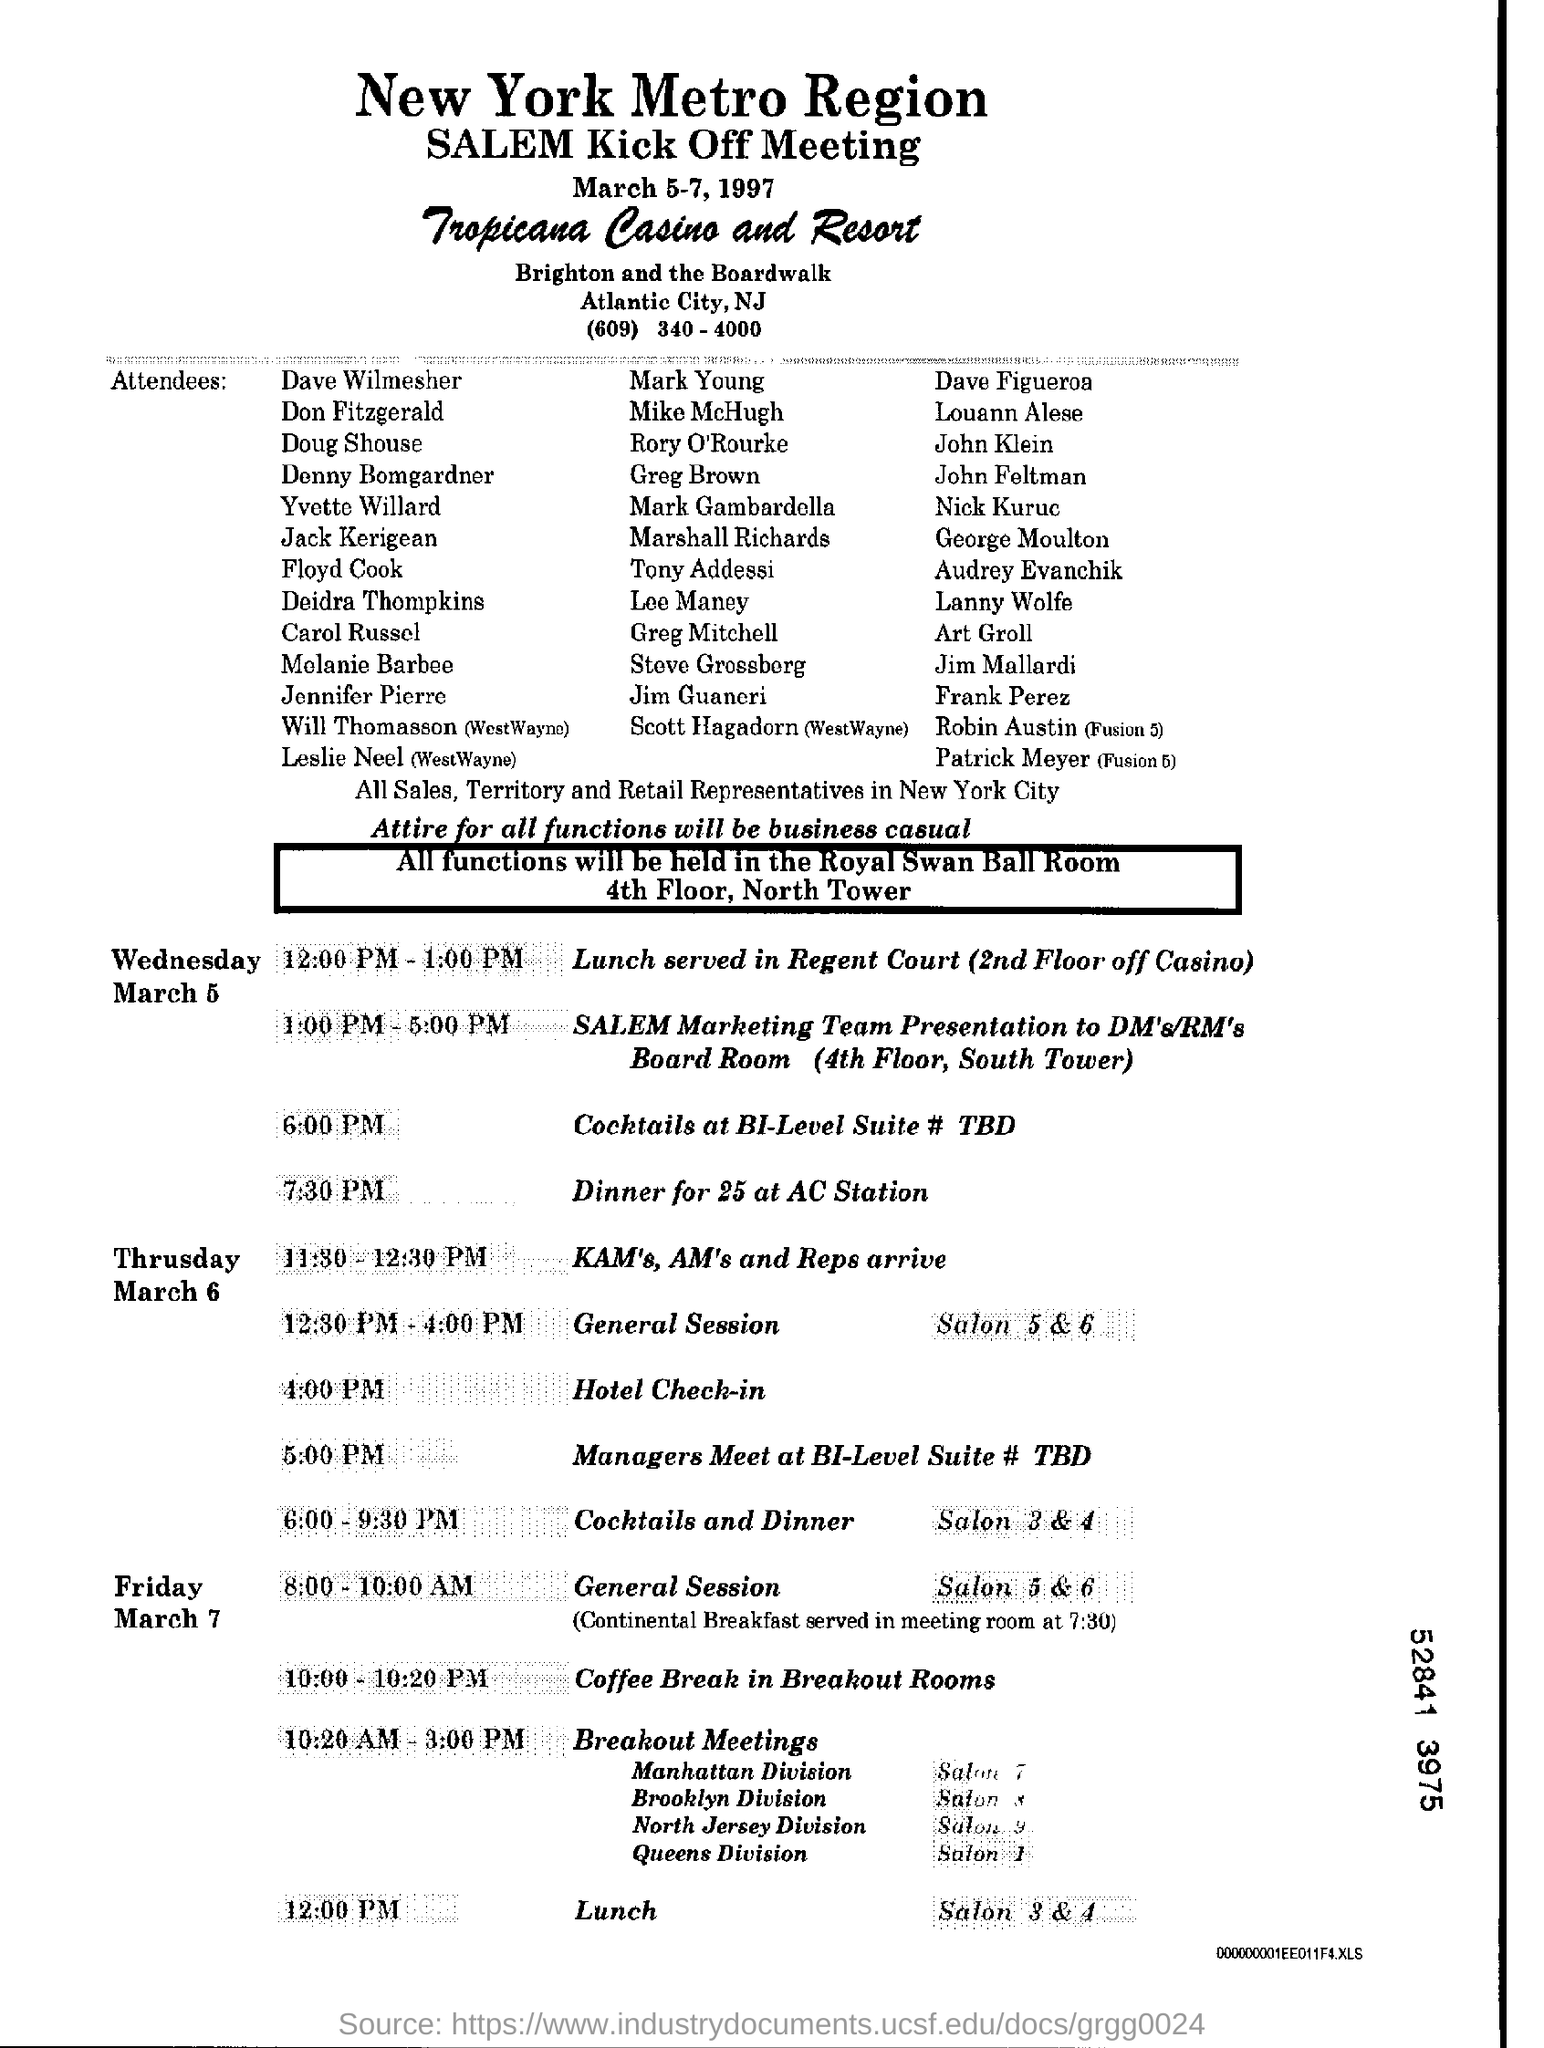What is the date mentioned in the top of the document ?
Your answer should be very brief. March 5-7, 1997. What is the Lunch Time of Friday ?
Provide a short and direct response. 12:00 PM. 